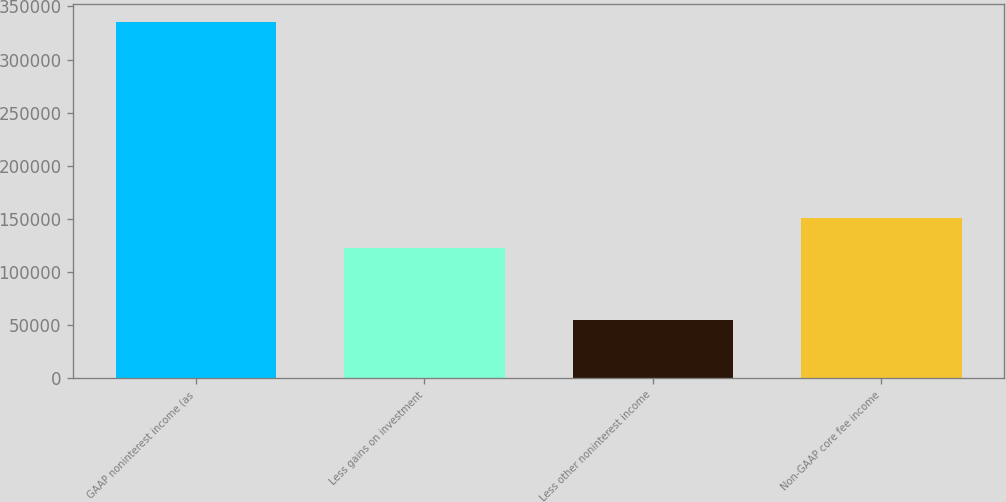<chart> <loc_0><loc_0><loc_500><loc_500><bar_chart><fcel>GAAP noninterest income (as<fcel>Less gains on investment<fcel>Less other noninterest income<fcel>Non-GAAP core fee income<nl><fcel>335546<fcel>122114<fcel>54401<fcel>150228<nl></chart> 